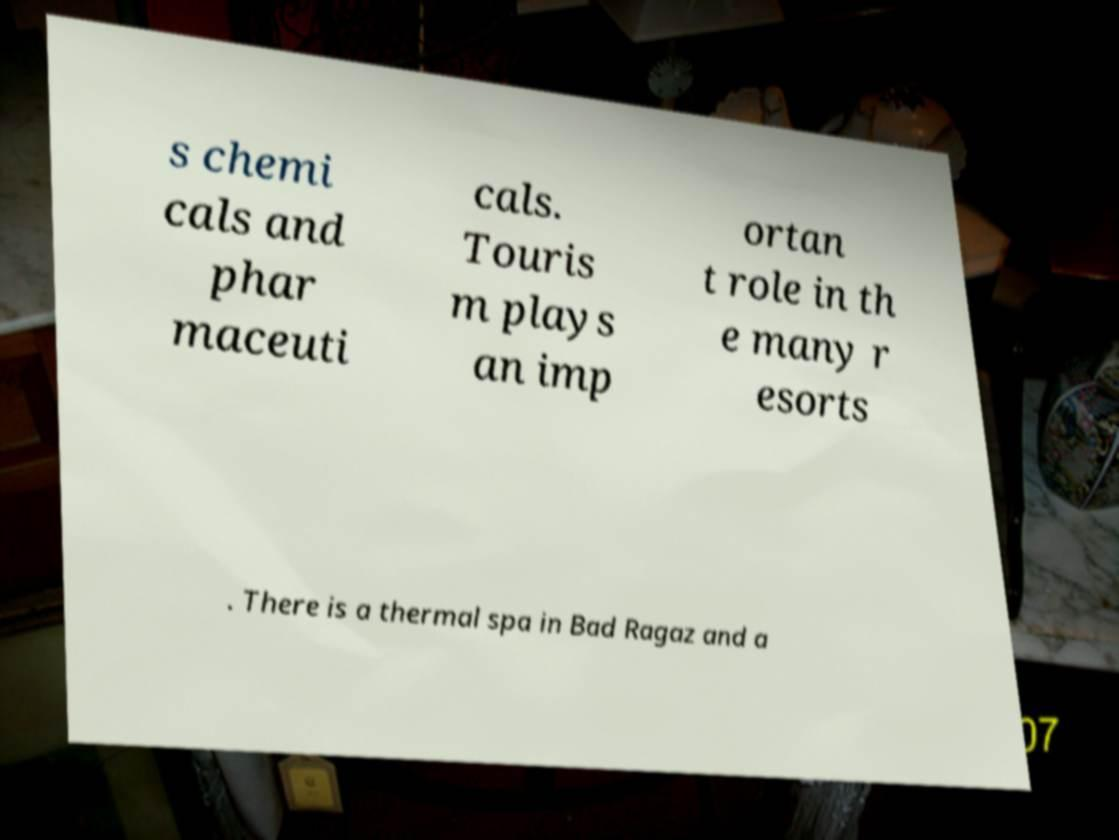I need the written content from this picture converted into text. Can you do that? s chemi cals and phar maceuti cals. Touris m plays an imp ortan t role in th e many r esorts . There is a thermal spa in Bad Ragaz and a 